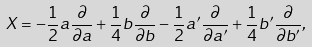Convert formula to latex. <formula><loc_0><loc_0><loc_500><loc_500>X = - \frac { 1 } { 2 } a \frac { \partial } { \partial a } + \frac { 1 } { 4 } b \frac { \partial } { \partial b } - \frac { 1 } { 2 } a ^ { \prime } \frac { \partial } { \partial a ^ { \prime } } + \frac { 1 } { 4 } b ^ { \prime } \frac { \partial } { \partial b ^ { \prime } } ,</formula> 